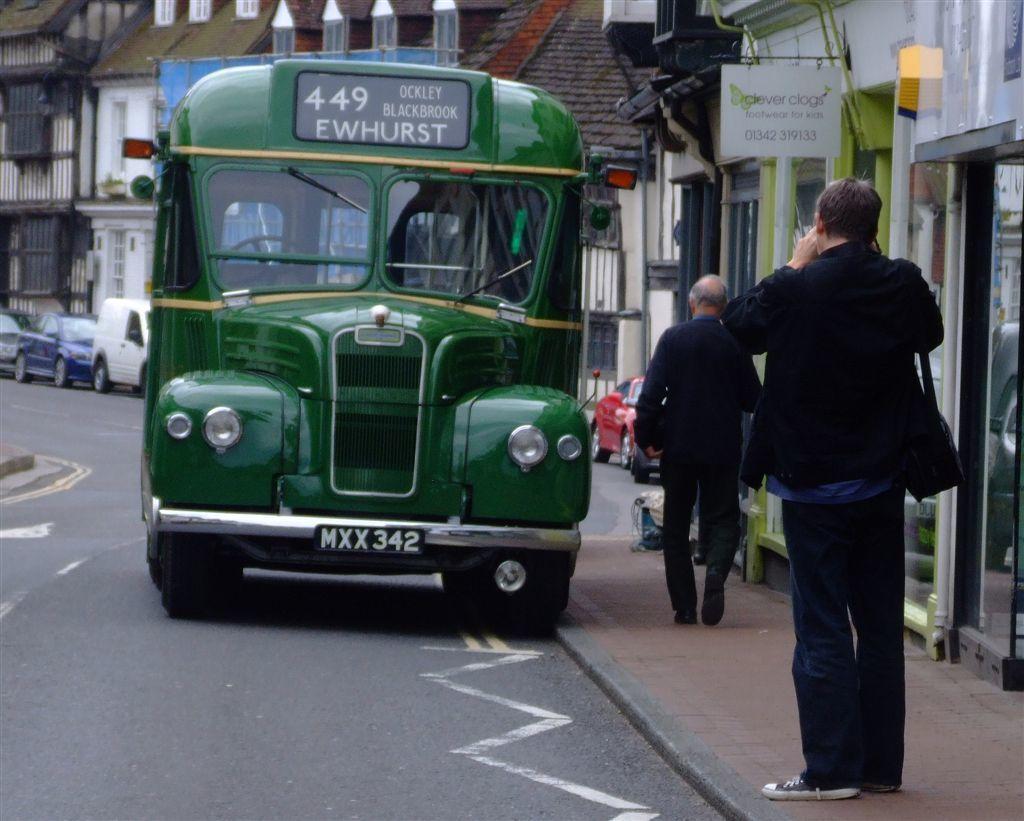How would you summarize this image in a sentence or two? In the picture we can see a front view of the bus on the road and beside it, we can see a path with two men are standing near the shop with glasses in it and behind the bus we can see some vehicles are parked near the houses. 